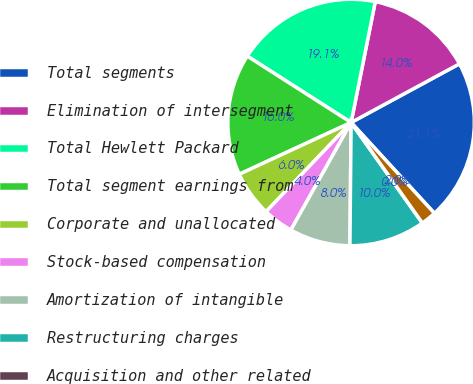<chart> <loc_0><loc_0><loc_500><loc_500><pie_chart><fcel>Total segments<fcel>Elimination of intersegment<fcel>Total Hewlett Packard<fcel>Total segment earnings from<fcel>Corporate and unallocated<fcel>Stock-based compensation<fcel>Amortization of intangible<fcel>Restructuring charges<fcel>Acquisition and other related<fcel>Interest and other net<nl><fcel>21.08%<fcel>13.96%<fcel>19.09%<fcel>15.95%<fcel>5.98%<fcel>3.99%<fcel>7.98%<fcel>9.97%<fcel>0.0%<fcel>2.0%<nl></chart> 